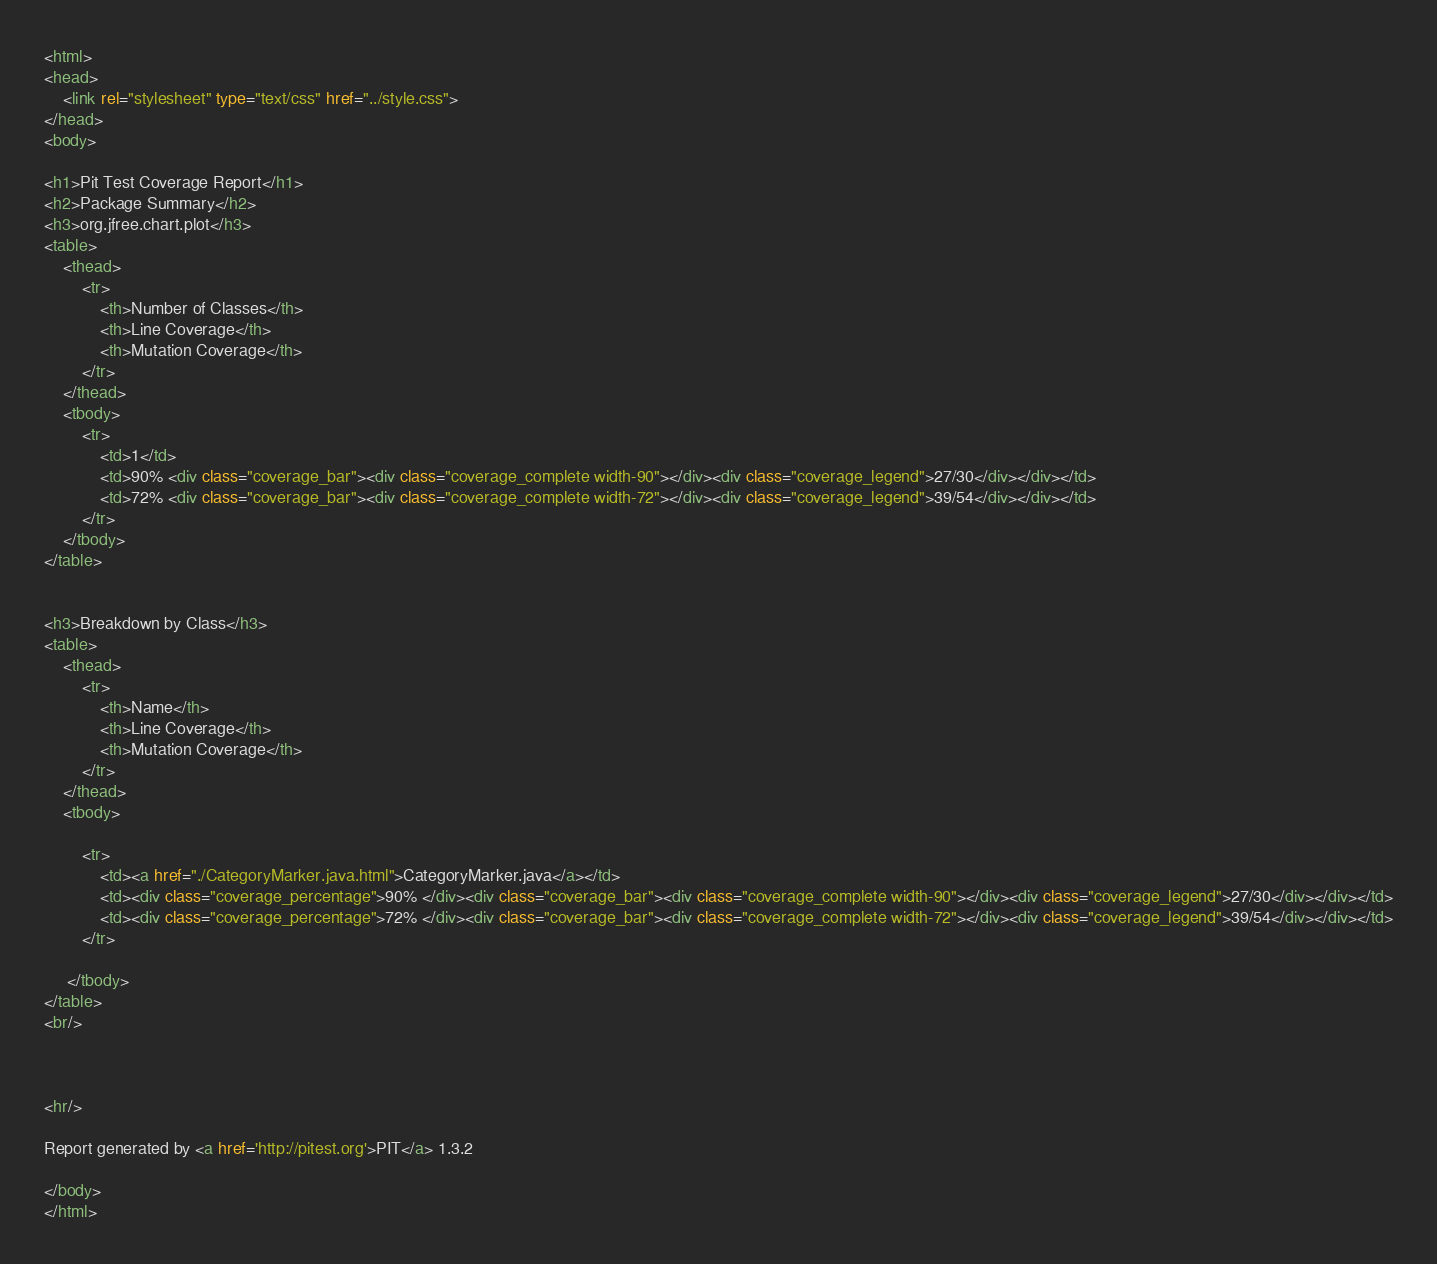<code> <loc_0><loc_0><loc_500><loc_500><_HTML_><html>
<head>
    <link rel="stylesheet" type="text/css" href="../style.css">
</head>
<body>

<h1>Pit Test Coverage Report</h1>
<h2>Package Summary</h2>
<h3>org.jfree.chart.plot</h3>
<table>
    <thead>
        <tr>
            <th>Number of Classes</th>
            <th>Line Coverage</th>
            <th>Mutation Coverage</th>
        </tr>
    </thead>
    <tbody>
        <tr>
            <td>1</td>
            <td>90% <div class="coverage_bar"><div class="coverage_complete width-90"></div><div class="coverage_legend">27/30</div></div></td>
            <td>72% <div class="coverage_bar"><div class="coverage_complete width-72"></div><div class="coverage_legend">39/54</div></div></td>
        </tr>
    </tbody>
</table>


<h3>Breakdown by Class</h3>
<table>
    <thead>
        <tr>
            <th>Name</th>
            <th>Line Coverage</th>
            <th>Mutation Coverage</th>
        </tr>
    </thead>
    <tbody>

        <tr>
            <td><a href="./CategoryMarker.java.html">CategoryMarker.java</a></td>
            <td><div class="coverage_percentage">90% </div><div class="coverage_bar"><div class="coverage_complete width-90"></div><div class="coverage_legend">27/30</div></div></td>
            <td><div class="coverage_percentage">72% </div><div class="coverage_bar"><div class="coverage_complete width-72"></div><div class="coverage_legend">39/54</div></div></td>
        </tr>

     </tbody>
</table>
<br/>



<hr/>

Report generated by <a href='http://pitest.org'>PIT</a> 1.3.2

</body>
</html></code> 